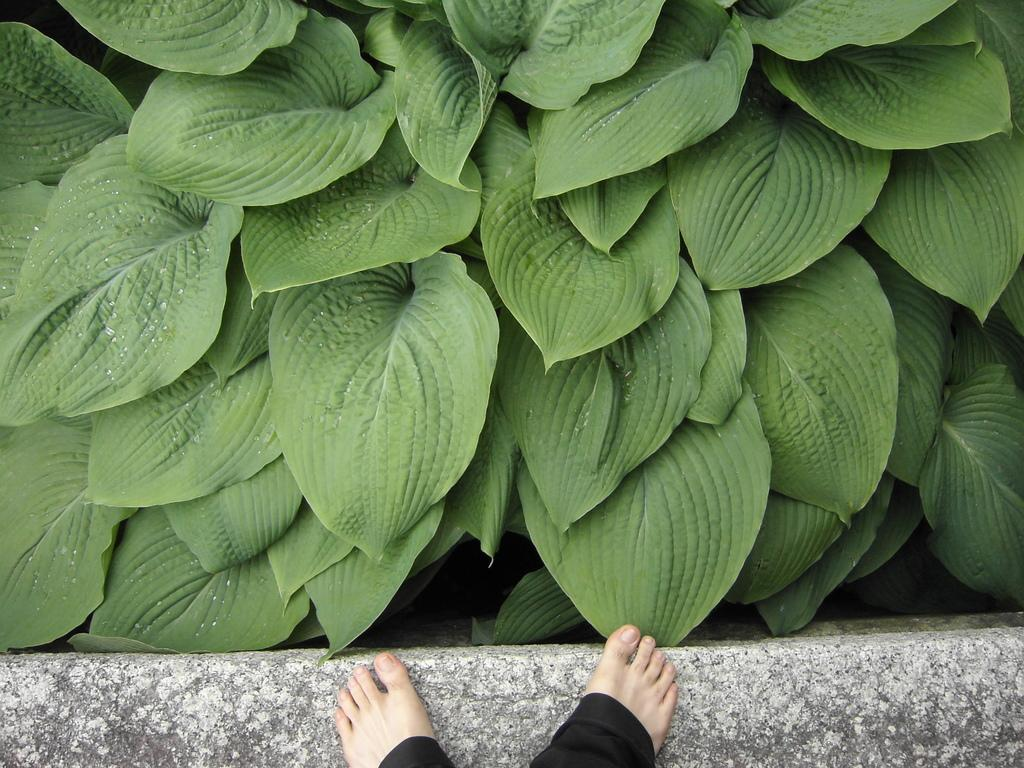What is located at the bottom of the image? There is a small wall at the bottom of the image. Can you describe what is near the wall? A person's toes are visible near the wall. What type of vegetation can be seen in the image? There are green leaves in the image. What type of ink is being used to write a letter in the image? There is no ink or letter present in the image. What action is the person performing with the leaves in the image? There is no action involving the leaves in the image; they are simply visible. 